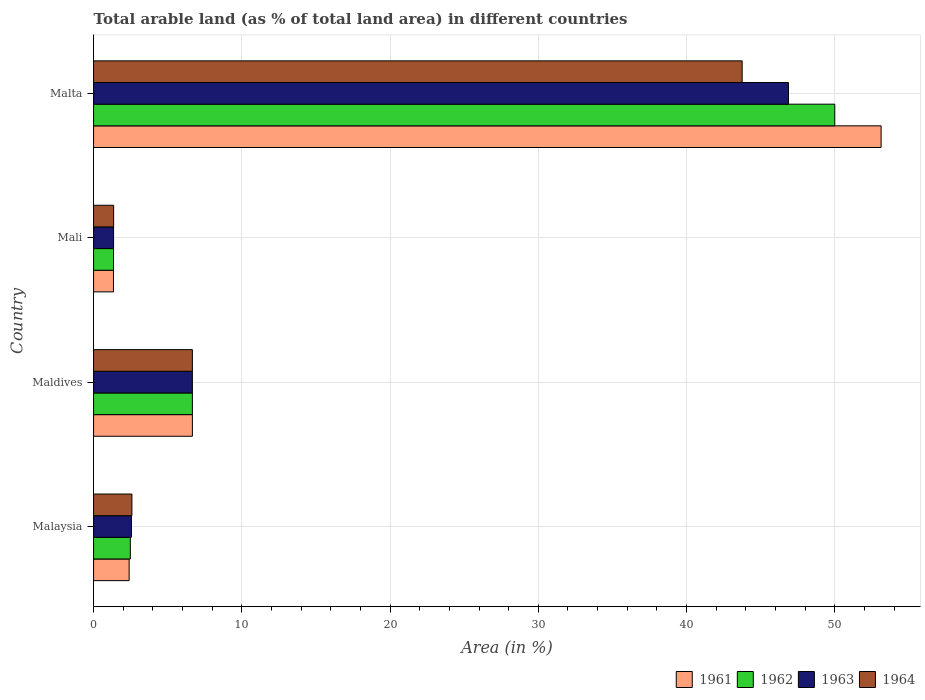How many different coloured bars are there?
Offer a terse response. 4. How many groups of bars are there?
Keep it short and to the point. 4. Are the number of bars per tick equal to the number of legend labels?
Offer a very short reply. Yes. How many bars are there on the 3rd tick from the bottom?
Keep it short and to the point. 4. What is the label of the 4th group of bars from the top?
Keep it short and to the point. Malaysia. What is the percentage of arable land in 1962 in Maldives?
Make the answer very short. 6.67. Across all countries, what is the minimum percentage of arable land in 1962?
Offer a terse response. 1.35. In which country was the percentage of arable land in 1963 maximum?
Provide a succinct answer. Malta. In which country was the percentage of arable land in 1964 minimum?
Provide a short and direct response. Mali. What is the total percentage of arable land in 1961 in the graph?
Ensure brevity in your answer.  63.53. What is the difference between the percentage of arable land in 1962 in Maldives and that in Mali?
Offer a very short reply. 5.32. What is the difference between the percentage of arable land in 1963 in Malaysia and the percentage of arable land in 1961 in Malta?
Make the answer very short. -50.57. What is the average percentage of arable land in 1961 per country?
Ensure brevity in your answer.  15.88. What is the difference between the percentage of arable land in 1963 and percentage of arable land in 1964 in Malaysia?
Give a very brief answer. -0.03. What is the ratio of the percentage of arable land in 1963 in Mali to that in Malta?
Offer a very short reply. 0.03. Is the difference between the percentage of arable land in 1963 in Malaysia and Malta greater than the difference between the percentage of arable land in 1964 in Malaysia and Malta?
Provide a short and direct response. No. What is the difference between the highest and the second highest percentage of arable land in 1962?
Your answer should be compact. 43.33. What is the difference between the highest and the lowest percentage of arable land in 1962?
Provide a succinct answer. 48.65. In how many countries, is the percentage of arable land in 1964 greater than the average percentage of arable land in 1964 taken over all countries?
Offer a terse response. 1. Is the sum of the percentage of arable land in 1962 in Mali and Malta greater than the maximum percentage of arable land in 1961 across all countries?
Keep it short and to the point. No. What does the 1st bar from the top in Mali represents?
Your answer should be very brief. 1964. What does the 4th bar from the bottom in Mali represents?
Offer a terse response. 1964. Are all the bars in the graph horizontal?
Keep it short and to the point. Yes. How many countries are there in the graph?
Provide a succinct answer. 4. What is the difference between two consecutive major ticks on the X-axis?
Offer a terse response. 10. Are the values on the major ticks of X-axis written in scientific E-notation?
Keep it short and to the point. No. Where does the legend appear in the graph?
Provide a short and direct response. Bottom right. What is the title of the graph?
Your answer should be compact. Total arable land (as % of total land area) in different countries. What is the label or title of the X-axis?
Your response must be concise. Area (in %). What is the label or title of the Y-axis?
Provide a short and direct response. Country. What is the Area (in %) in 1961 in Malaysia?
Provide a succinct answer. 2.4. What is the Area (in %) of 1962 in Malaysia?
Offer a terse response. 2.48. What is the Area (in %) in 1963 in Malaysia?
Provide a succinct answer. 2.55. What is the Area (in %) in 1964 in Malaysia?
Provide a short and direct response. 2.59. What is the Area (in %) of 1961 in Maldives?
Your answer should be compact. 6.67. What is the Area (in %) in 1962 in Maldives?
Keep it short and to the point. 6.67. What is the Area (in %) in 1963 in Maldives?
Your answer should be very brief. 6.67. What is the Area (in %) in 1964 in Maldives?
Keep it short and to the point. 6.67. What is the Area (in %) in 1961 in Mali?
Keep it short and to the point. 1.34. What is the Area (in %) in 1962 in Mali?
Make the answer very short. 1.35. What is the Area (in %) of 1963 in Mali?
Your response must be concise. 1.35. What is the Area (in %) in 1964 in Mali?
Offer a very short reply. 1.35. What is the Area (in %) of 1961 in Malta?
Ensure brevity in your answer.  53.12. What is the Area (in %) in 1963 in Malta?
Give a very brief answer. 46.88. What is the Area (in %) of 1964 in Malta?
Ensure brevity in your answer.  43.75. Across all countries, what is the maximum Area (in %) of 1961?
Make the answer very short. 53.12. Across all countries, what is the maximum Area (in %) of 1963?
Offer a very short reply. 46.88. Across all countries, what is the maximum Area (in %) in 1964?
Your answer should be very brief. 43.75. Across all countries, what is the minimum Area (in %) of 1961?
Make the answer very short. 1.34. Across all countries, what is the minimum Area (in %) of 1962?
Keep it short and to the point. 1.35. Across all countries, what is the minimum Area (in %) in 1963?
Your answer should be very brief. 1.35. Across all countries, what is the minimum Area (in %) of 1964?
Provide a succinct answer. 1.35. What is the total Area (in %) in 1961 in the graph?
Keep it short and to the point. 63.53. What is the total Area (in %) in 1962 in the graph?
Your answer should be very brief. 60.49. What is the total Area (in %) of 1963 in the graph?
Offer a terse response. 57.45. What is the total Area (in %) in 1964 in the graph?
Your answer should be very brief. 54.36. What is the difference between the Area (in %) of 1961 in Malaysia and that in Maldives?
Your response must be concise. -4.27. What is the difference between the Area (in %) in 1962 in Malaysia and that in Maldives?
Provide a succinct answer. -4.19. What is the difference between the Area (in %) in 1963 in Malaysia and that in Maldives?
Your answer should be very brief. -4.11. What is the difference between the Area (in %) in 1964 in Malaysia and that in Maldives?
Offer a very short reply. -4.08. What is the difference between the Area (in %) in 1961 in Malaysia and that in Mali?
Keep it short and to the point. 1.06. What is the difference between the Area (in %) in 1962 in Malaysia and that in Mali?
Ensure brevity in your answer.  1.13. What is the difference between the Area (in %) of 1963 in Malaysia and that in Mali?
Give a very brief answer. 1.2. What is the difference between the Area (in %) in 1964 in Malaysia and that in Mali?
Make the answer very short. 1.23. What is the difference between the Area (in %) in 1961 in Malaysia and that in Malta?
Provide a succinct answer. -50.73. What is the difference between the Area (in %) of 1962 in Malaysia and that in Malta?
Provide a short and direct response. -47.52. What is the difference between the Area (in %) of 1963 in Malaysia and that in Malta?
Ensure brevity in your answer.  -44.32. What is the difference between the Area (in %) in 1964 in Malaysia and that in Malta?
Provide a short and direct response. -41.16. What is the difference between the Area (in %) of 1961 in Maldives and that in Mali?
Give a very brief answer. 5.32. What is the difference between the Area (in %) of 1962 in Maldives and that in Mali?
Offer a terse response. 5.32. What is the difference between the Area (in %) of 1963 in Maldives and that in Mali?
Your response must be concise. 5.32. What is the difference between the Area (in %) of 1964 in Maldives and that in Mali?
Provide a short and direct response. 5.31. What is the difference between the Area (in %) of 1961 in Maldives and that in Malta?
Make the answer very short. -46.46. What is the difference between the Area (in %) in 1962 in Maldives and that in Malta?
Offer a very short reply. -43.33. What is the difference between the Area (in %) of 1963 in Maldives and that in Malta?
Offer a terse response. -40.21. What is the difference between the Area (in %) in 1964 in Maldives and that in Malta?
Keep it short and to the point. -37.08. What is the difference between the Area (in %) of 1961 in Mali and that in Malta?
Offer a very short reply. -51.78. What is the difference between the Area (in %) of 1962 in Mali and that in Malta?
Provide a short and direct response. -48.65. What is the difference between the Area (in %) of 1963 in Mali and that in Malta?
Provide a succinct answer. -45.52. What is the difference between the Area (in %) of 1964 in Mali and that in Malta?
Make the answer very short. -42.4. What is the difference between the Area (in %) of 1961 in Malaysia and the Area (in %) of 1962 in Maldives?
Your response must be concise. -4.27. What is the difference between the Area (in %) in 1961 in Malaysia and the Area (in %) in 1963 in Maldives?
Keep it short and to the point. -4.27. What is the difference between the Area (in %) in 1961 in Malaysia and the Area (in %) in 1964 in Maldives?
Your answer should be very brief. -4.27. What is the difference between the Area (in %) of 1962 in Malaysia and the Area (in %) of 1963 in Maldives?
Your answer should be very brief. -4.19. What is the difference between the Area (in %) in 1962 in Malaysia and the Area (in %) in 1964 in Maldives?
Your response must be concise. -4.19. What is the difference between the Area (in %) in 1963 in Malaysia and the Area (in %) in 1964 in Maldives?
Provide a short and direct response. -4.11. What is the difference between the Area (in %) in 1961 in Malaysia and the Area (in %) in 1962 in Mali?
Keep it short and to the point. 1.05. What is the difference between the Area (in %) of 1961 in Malaysia and the Area (in %) of 1963 in Mali?
Provide a succinct answer. 1.05. What is the difference between the Area (in %) in 1961 in Malaysia and the Area (in %) in 1964 in Mali?
Give a very brief answer. 1.05. What is the difference between the Area (in %) of 1962 in Malaysia and the Area (in %) of 1963 in Mali?
Provide a short and direct response. 1.13. What is the difference between the Area (in %) of 1962 in Malaysia and the Area (in %) of 1964 in Mali?
Keep it short and to the point. 1.13. What is the difference between the Area (in %) of 1963 in Malaysia and the Area (in %) of 1964 in Mali?
Your answer should be very brief. 1.2. What is the difference between the Area (in %) of 1961 in Malaysia and the Area (in %) of 1962 in Malta?
Your answer should be very brief. -47.6. What is the difference between the Area (in %) of 1961 in Malaysia and the Area (in %) of 1963 in Malta?
Your answer should be very brief. -44.48. What is the difference between the Area (in %) of 1961 in Malaysia and the Area (in %) of 1964 in Malta?
Ensure brevity in your answer.  -41.35. What is the difference between the Area (in %) of 1962 in Malaysia and the Area (in %) of 1963 in Malta?
Give a very brief answer. -44.4. What is the difference between the Area (in %) in 1962 in Malaysia and the Area (in %) in 1964 in Malta?
Offer a very short reply. -41.27. What is the difference between the Area (in %) of 1963 in Malaysia and the Area (in %) of 1964 in Malta?
Provide a short and direct response. -41.2. What is the difference between the Area (in %) of 1961 in Maldives and the Area (in %) of 1962 in Mali?
Your response must be concise. 5.32. What is the difference between the Area (in %) of 1961 in Maldives and the Area (in %) of 1963 in Mali?
Your response must be concise. 5.32. What is the difference between the Area (in %) of 1961 in Maldives and the Area (in %) of 1964 in Mali?
Keep it short and to the point. 5.31. What is the difference between the Area (in %) of 1962 in Maldives and the Area (in %) of 1963 in Mali?
Provide a succinct answer. 5.32. What is the difference between the Area (in %) of 1962 in Maldives and the Area (in %) of 1964 in Mali?
Your response must be concise. 5.31. What is the difference between the Area (in %) in 1963 in Maldives and the Area (in %) in 1964 in Mali?
Offer a very short reply. 5.31. What is the difference between the Area (in %) in 1961 in Maldives and the Area (in %) in 1962 in Malta?
Your answer should be very brief. -43.33. What is the difference between the Area (in %) of 1961 in Maldives and the Area (in %) of 1963 in Malta?
Keep it short and to the point. -40.21. What is the difference between the Area (in %) in 1961 in Maldives and the Area (in %) in 1964 in Malta?
Give a very brief answer. -37.08. What is the difference between the Area (in %) of 1962 in Maldives and the Area (in %) of 1963 in Malta?
Your response must be concise. -40.21. What is the difference between the Area (in %) in 1962 in Maldives and the Area (in %) in 1964 in Malta?
Give a very brief answer. -37.08. What is the difference between the Area (in %) of 1963 in Maldives and the Area (in %) of 1964 in Malta?
Make the answer very short. -37.08. What is the difference between the Area (in %) of 1961 in Mali and the Area (in %) of 1962 in Malta?
Give a very brief answer. -48.66. What is the difference between the Area (in %) in 1961 in Mali and the Area (in %) in 1963 in Malta?
Your response must be concise. -45.53. What is the difference between the Area (in %) in 1961 in Mali and the Area (in %) in 1964 in Malta?
Your answer should be compact. -42.41. What is the difference between the Area (in %) in 1962 in Mali and the Area (in %) in 1963 in Malta?
Offer a terse response. -45.53. What is the difference between the Area (in %) of 1962 in Mali and the Area (in %) of 1964 in Malta?
Your answer should be very brief. -42.4. What is the difference between the Area (in %) in 1963 in Mali and the Area (in %) in 1964 in Malta?
Your answer should be very brief. -42.4. What is the average Area (in %) of 1961 per country?
Provide a succinct answer. 15.88. What is the average Area (in %) in 1962 per country?
Ensure brevity in your answer.  15.12. What is the average Area (in %) of 1963 per country?
Provide a succinct answer. 14.36. What is the average Area (in %) of 1964 per country?
Provide a short and direct response. 13.59. What is the difference between the Area (in %) in 1961 and Area (in %) in 1962 in Malaysia?
Make the answer very short. -0.08. What is the difference between the Area (in %) of 1961 and Area (in %) of 1963 in Malaysia?
Your response must be concise. -0.15. What is the difference between the Area (in %) of 1961 and Area (in %) of 1964 in Malaysia?
Provide a succinct answer. -0.19. What is the difference between the Area (in %) of 1962 and Area (in %) of 1963 in Malaysia?
Your answer should be compact. -0.07. What is the difference between the Area (in %) in 1962 and Area (in %) in 1964 in Malaysia?
Your response must be concise. -0.11. What is the difference between the Area (in %) in 1963 and Area (in %) in 1964 in Malaysia?
Give a very brief answer. -0.03. What is the difference between the Area (in %) in 1961 and Area (in %) in 1962 in Maldives?
Keep it short and to the point. 0. What is the difference between the Area (in %) in 1962 and Area (in %) in 1963 in Maldives?
Give a very brief answer. 0. What is the difference between the Area (in %) in 1961 and Area (in %) in 1962 in Mali?
Provide a short and direct response. -0. What is the difference between the Area (in %) in 1961 and Area (in %) in 1963 in Mali?
Offer a very short reply. -0.01. What is the difference between the Area (in %) in 1961 and Area (in %) in 1964 in Mali?
Your response must be concise. -0.01. What is the difference between the Area (in %) of 1962 and Area (in %) of 1963 in Mali?
Your answer should be compact. -0. What is the difference between the Area (in %) in 1962 and Area (in %) in 1964 in Mali?
Offer a terse response. -0.01. What is the difference between the Area (in %) of 1963 and Area (in %) of 1964 in Mali?
Provide a short and direct response. -0. What is the difference between the Area (in %) of 1961 and Area (in %) of 1962 in Malta?
Offer a terse response. 3.12. What is the difference between the Area (in %) of 1961 and Area (in %) of 1963 in Malta?
Your response must be concise. 6.25. What is the difference between the Area (in %) of 1961 and Area (in %) of 1964 in Malta?
Give a very brief answer. 9.38. What is the difference between the Area (in %) of 1962 and Area (in %) of 1963 in Malta?
Your response must be concise. 3.12. What is the difference between the Area (in %) of 1962 and Area (in %) of 1964 in Malta?
Your answer should be very brief. 6.25. What is the difference between the Area (in %) of 1963 and Area (in %) of 1964 in Malta?
Provide a short and direct response. 3.12. What is the ratio of the Area (in %) of 1961 in Malaysia to that in Maldives?
Give a very brief answer. 0.36. What is the ratio of the Area (in %) of 1962 in Malaysia to that in Maldives?
Keep it short and to the point. 0.37. What is the ratio of the Area (in %) in 1963 in Malaysia to that in Maldives?
Give a very brief answer. 0.38. What is the ratio of the Area (in %) of 1964 in Malaysia to that in Maldives?
Your answer should be compact. 0.39. What is the ratio of the Area (in %) of 1961 in Malaysia to that in Mali?
Your answer should be very brief. 1.79. What is the ratio of the Area (in %) in 1962 in Malaysia to that in Mali?
Your answer should be compact. 1.84. What is the ratio of the Area (in %) of 1963 in Malaysia to that in Mali?
Keep it short and to the point. 1.89. What is the ratio of the Area (in %) of 1964 in Malaysia to that in Mali?
Your answer should be very brief. 1.91. What is the ratio of the Area (in %) of 1961 in Malaysia to that in Malta?
Ensure brevity in your answer.  0.05. What is the ratio of the Area (in %) in 1962 in Malaysia to that in Malta?
Your response must be concise. 0.05. What is the ratio of the Area (in %) in 1963 in Malaysia to that in Malta?
Your response must be concise. 0.05. What is the ratio of the Area (in %) of 1964 in Malaysia to that in Malta?
Your answer should be very brief. 0.06. What is the ratio of the Area (in %) in 1961 in Maldives to that in Mali?
Provide a succinct answer. 4.97. What is the ratio of the Area (in %) of 1962 in Maldives to that in Mali?
Provide a succinct answer. 4.95. What is the ratio of the Area (in %) of 1963 in Maldives to that in Mali?
Offer a terse response. 4.94. What is the ratio of the Area (in %) in 1964 in Maldives to that in Mali?
Keep it short and to the point. 4.92. What is the ratio of the Area (in %) of 1961 in Maldives to that in Malta?
Provide a succinct answer. 0.13. What is the ratio of the Area (in %) in 1962 in Maldives to that in Malta?
Offer a very short reply. 0.13. What is the ratio of the Area (in %) in 1963 in Maldives to that in Malta?
Offer a very short reply. 0.14. What is the ratio of the Area (in %) of 1964 in Maldives to that in Malta?
Give a very brief answer. 0.15. What is the ratio of the Area (in %) in 1961 in Mali to that in Malta?
Provide a short and direct response. 0.03. What is the ratio of the Area (in %) in 1962 in Mali to that in Malta?
Keep it short and to the point. 0.03. What is the ratio of the Area (in %) of 1963 in Mali to that in Malta?
Offer a very short reply. 0.03. What is the ratio of the Area (in %) in 1964 in Mali to that in Malta?
Give a very brief answer. 0.03. What is the difference between the highest and the second highest Area (in %) of 1961?
Ensure brevity in your answer.  46.46. What is the difference between the highest and the second highest Area (in %) in 1962?
Provide a succinct answer. 43.33. What is the difference between the highest and the second highest Area (in %) of 1963?
Keep it short and to the point. 40.21. What is the difference between the highest and the second highest Area (in %) of 1964?
Your response must be concise. 37.08. What is the difference between the highest and the lowest Area (in %) of 1961?
Offer a very short reply. 51.78. What is the difference between the highest and the lowest Area (in %) in 1962?
Your answer should be very brief. 48.65. What is the difference between the highest and the lowest Area (in %) in 1963?
Your answer should be very brief. 45.52. What is the difference between the highest and the lowest Area (in %) in 1964?
Offer a very short reply. 42.4. 